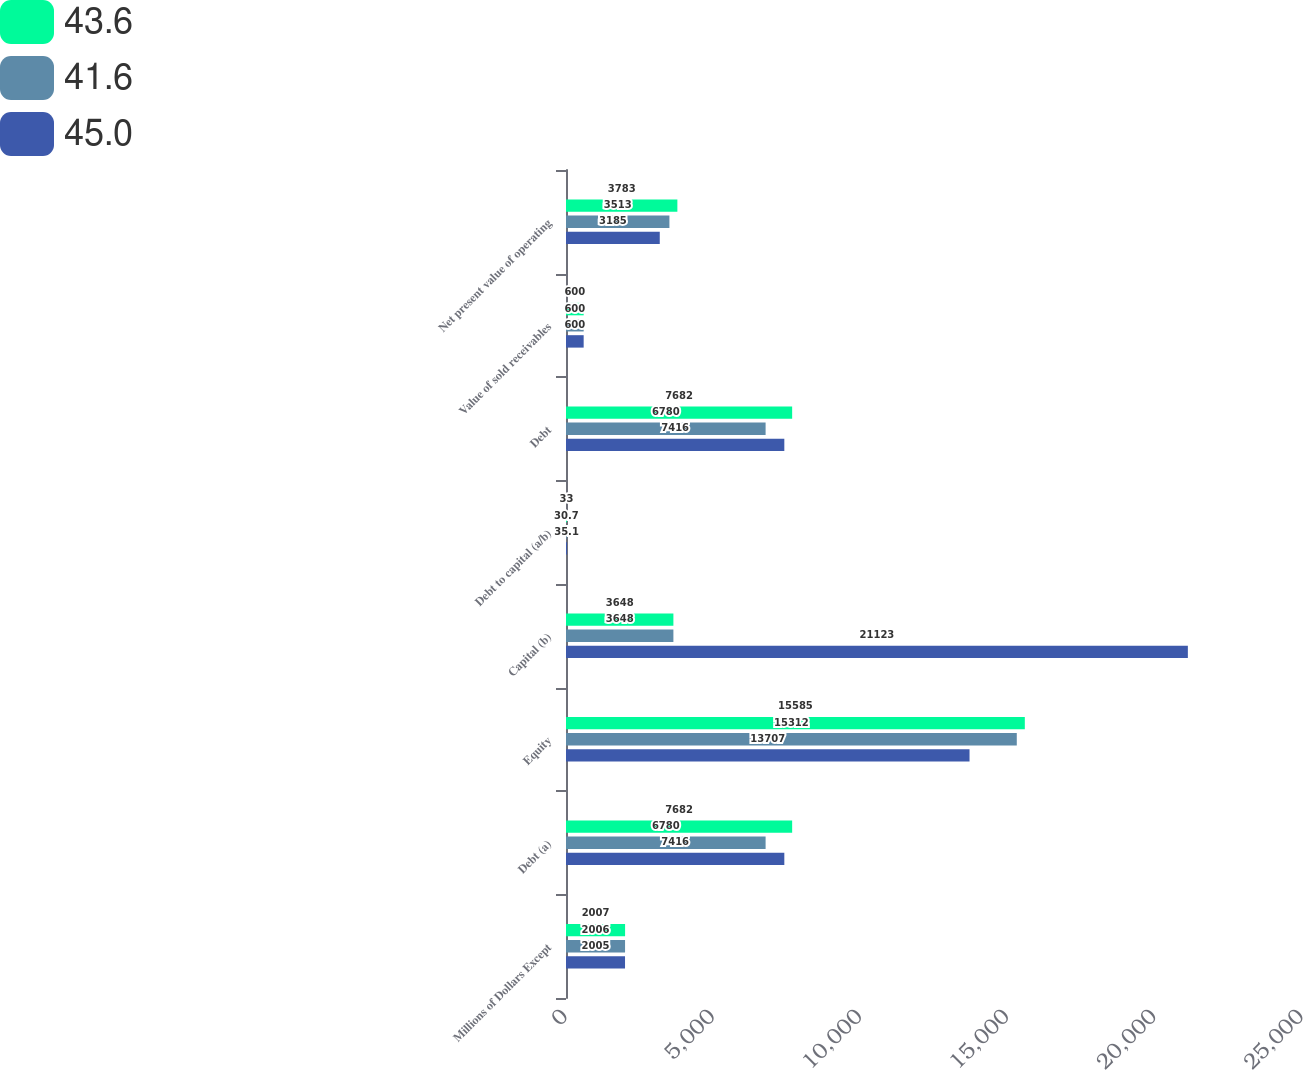Convert chart to OTSL. <chart><loc_0><loc_0><loc_500><loc_500><stacked_bar_chart><ecel><fcel>Millions of Dollars Except<fcel>Debt (a)<fcel>Equity<fcel>Capital (b)<fcel>Debt to capital (a/b)<fcel>Debt<fcel>Value of sold receivables<fcel>Net present value of operating<nl><fcel>43.6<fcel>2007<fcel>7682<fcel>15585<fcel>3648<fcel>33<fcel>7682<fcel>600<fcel>3783<nl><fcel>41.6<fcel>2006<fcel>6780<fcel>15312<fcel>3648<fcel>30.7<fcel>6780<fcel>600<fcel>3513<nl><fcel>45<fcel>2005<fcel>7416<fcel>13707<fcel>21123<fcel>35.1<fcel>7416<fcel>600<fcel>3185<nl></chart> 